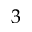<formula> <loc_0><loc_0><loc_500><loc_500>3</formula> 